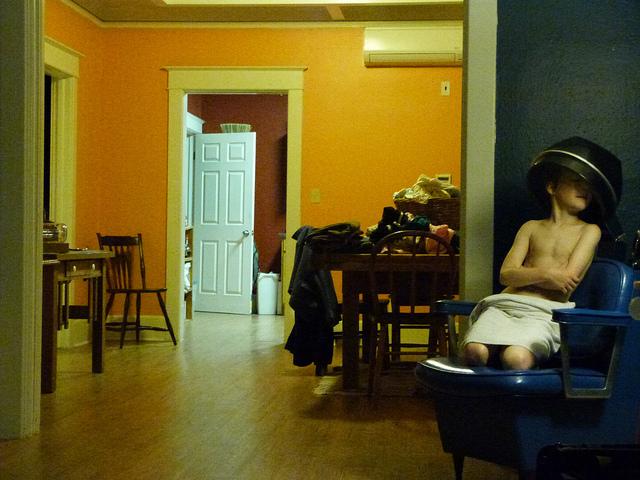Is it a boy under the hairdryer?
Write a very short answer. Yes. What is the blue chair called?
Keep it brief. Hair dryer. Is someone sitting in the chair?
Concise answer only. Yes. How many chairs are in this photo?
Keep it brief. 3. What is on top of the armchair?
Short answer required. Boy. 